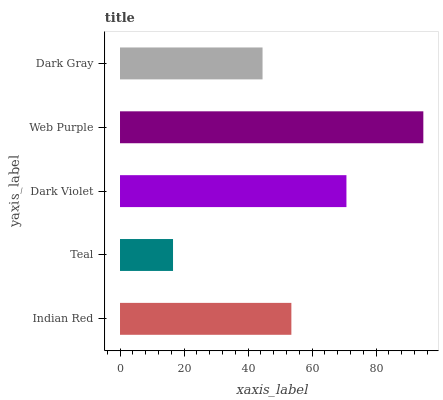Is Teal the minimum?
Answer yes or no. Yes. Is Web Purple the maximum?
Answer yes or no. Yes. Is Dark Violet the minimum?
Answer yes or no. No. Is Dark Violet the maximum?
Answer yes or no. No. Is Dark Violet greater than Teal?
Answer yes or no. Yes. Is Teal less than Dark Violet?
Answer yes or no. Yes. Is Teal greater than Dark Violet?
Answer yes or no. No. Is Dark Violet less than Teal?
Answer yes or no. No. Is Indian Red the high median?
Answer yes or no. Yes. Is Indian Red the low median?
Answer yes or no. Yes. Is Web Purple the high median?
Answer yes or no. No. Is Web Purple the low median?
Answer yes or no. No. 